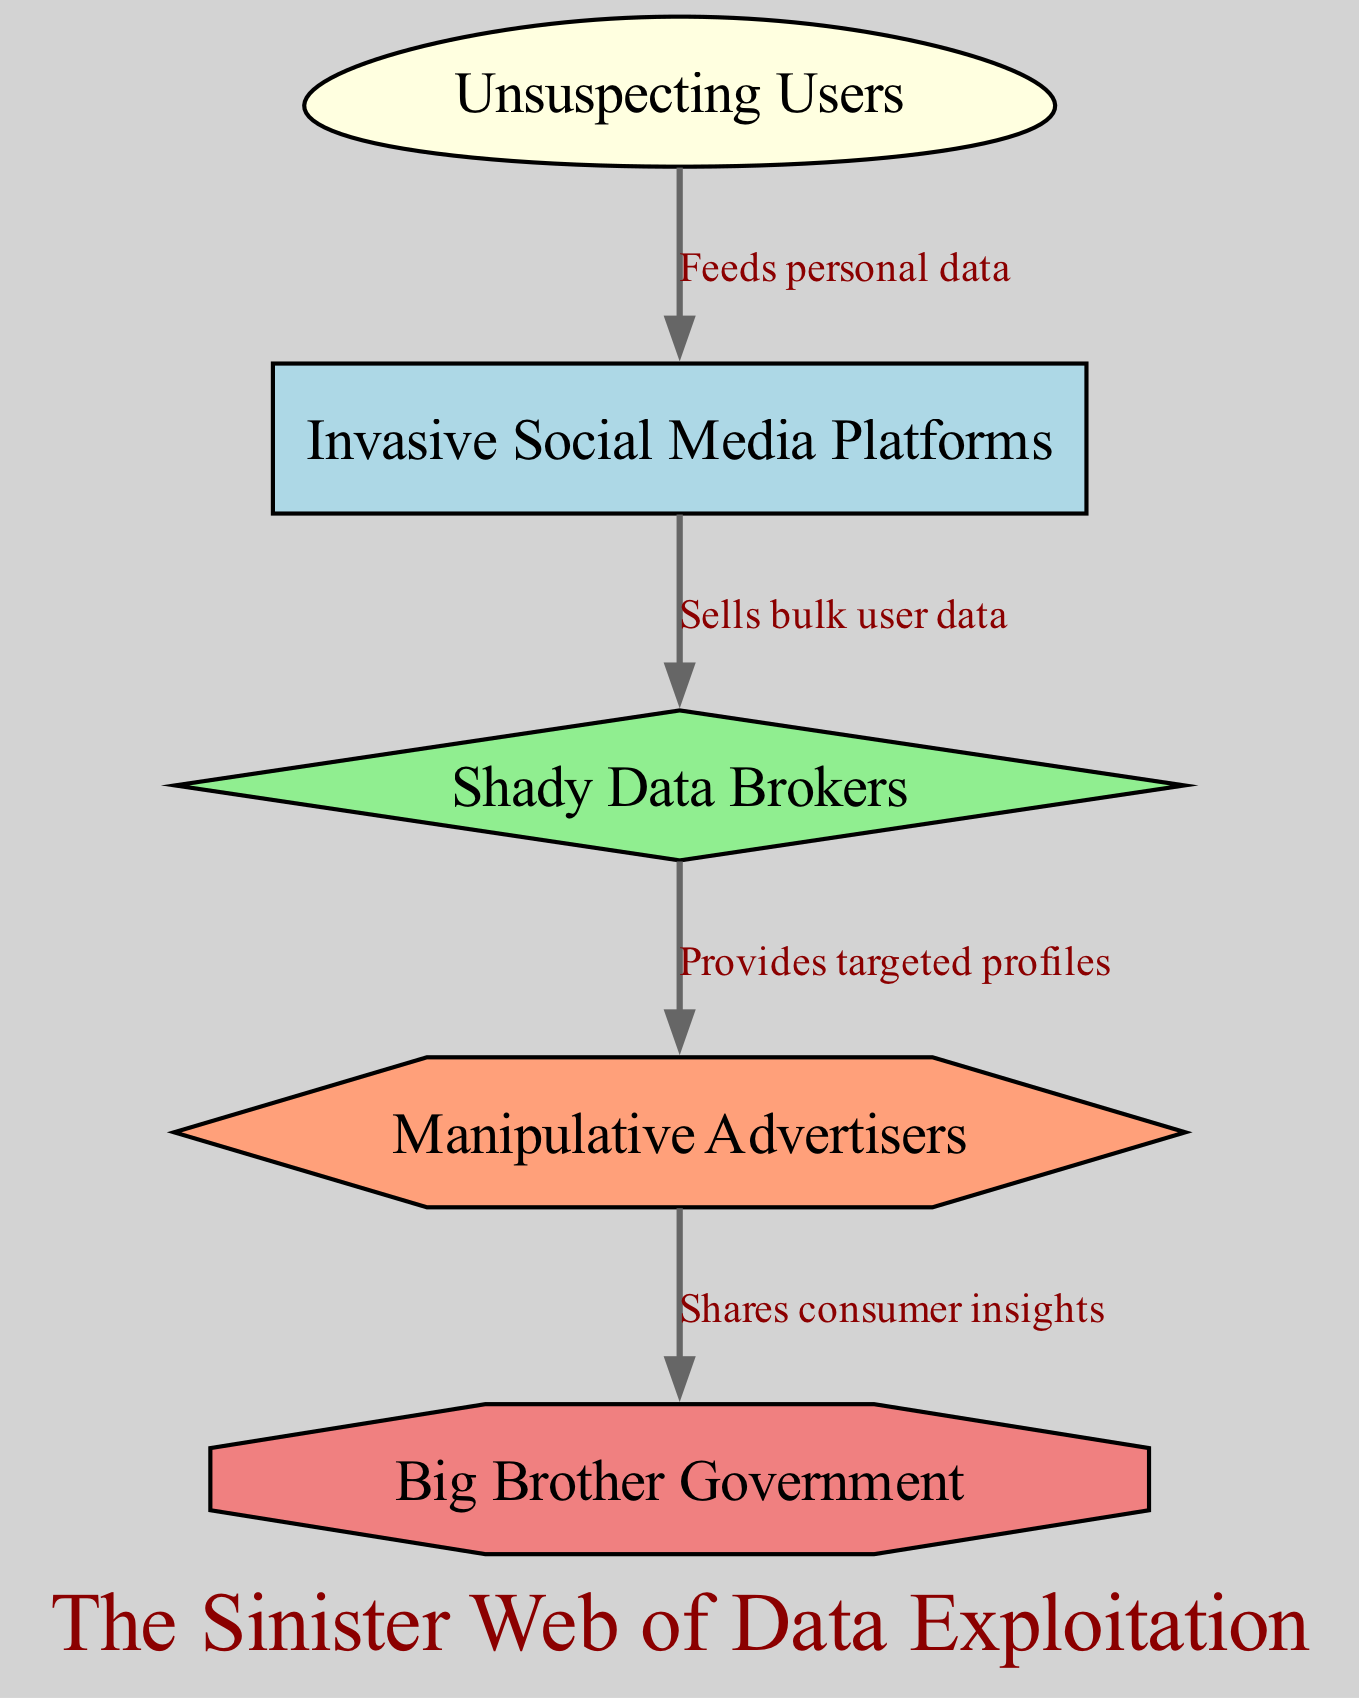What is the first element in the diagram? The first element listed in the diagram is "Unsuspecting Users." This is identified by finding the element with the lowest level (1) in the data provided.
Answer: Unsuspecting Users How many total nodes are in the diagram? The diagram contains five nodes, which can be counted from the data elements. Each unique id in the "elements" list corresponds to one node.
Answer: 5 What relationship exists between "Invasive Social Media Platforms" and "Shady Data Brokers"? The relationship is indicated by the edge labeled "Sells bulk user data," which connects these two nodes. This indicates the data flow from social media platforms to data brokers.
Answer: Sells bulk user data Who provides targeted profiles to advertisers? The node "Shady Data Brokers" is noted to provide targeted profiles to advertisers, as indicated by the specific relationship labeled "Provides targeted profiles" in the diagram.
Answer: Shady Data Brokers Which entity shares consumer insights with the government? The relationship labeled "Shares consumer insights" indicates that "Manipulative Advertisers" are the entity sharing consumer insights with "Big Brother Government."
Answer: Manipulative Advertisers If users stop using social media, which node is directly affected? The "Invasive Social Media Platforms" node would be directly affected, as it is the first node that receives data from "Unsuspecting Users." If the users stop providing data, this node would see a direct impact.
Answer: Invasive Social Media Platforms What is the flow direction of data from "data_brokers" to "advertisers"? The flow direction is indicated by the edge in the diagram. It shows that data flows from "data_brokers" to "advertisers," specifically indicated by the label "Provides targeted profiles."
Answer: Provides targeted profiles What color represents the "Big Brother Government" node? The "Big Brother Government" node is colored light coral, as indicated by the node styles defined in the diagram's code section.
Answer: Light coral What is the last level in the diagram? The last level is 5, represented by the node "Big Brother Government." This is determined by looking at the highest level defined in the data elements.
Answer: 5 